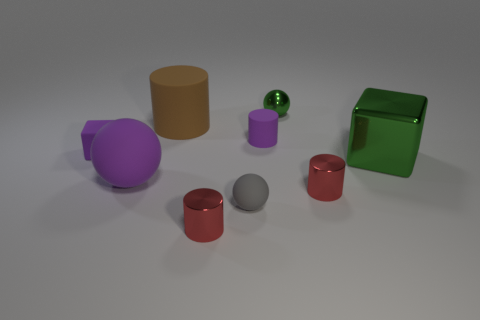Subtract all red balls. Subtract all blue cubes. How many balls are left? 3 Add 1 green cubes. How many objects exist? 10 Subtract all cylinders. How many objects are left? 5 Add 7 big green things. How many big green things are left? 8 Add 6 gray balls. How many gray balls exist? 7 Subtract 0 cyan cylinders. How many objects are left? 9 Subtract all small green things. Subtract all brown metal cubes. How many objects are left? 8 